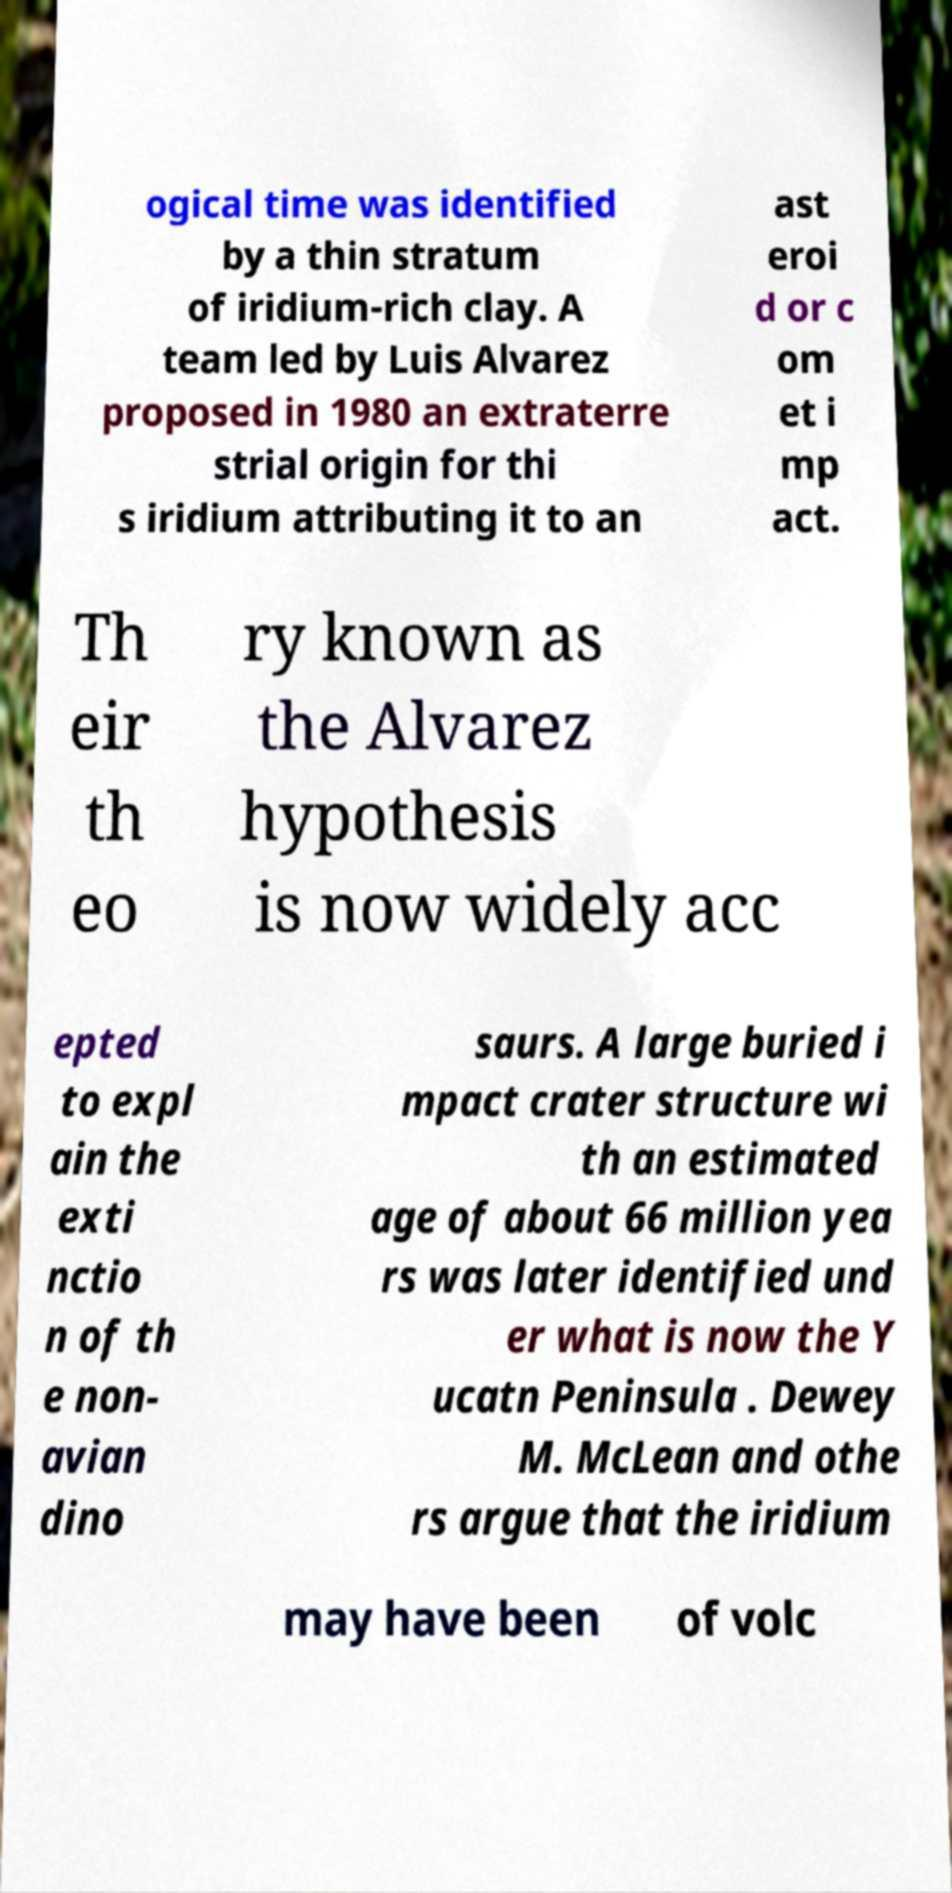Could you extract and type out the text from this image? ogical time was identified by a thin stratum of iridium-rich clay. A team led by Luis Alvarez proposed in 1980 an extraterre strial origin for thi s iridium attributing it to an ast eroi d or c om et i mp act. Th eir th eo ry known as the Alvarez hypothesis is now widely acc epted to expl ain the exti nctio n of th e non- avian dino saurs. A large buried i mpact crater structure wi th an estimated age of about 66 million yea rs was later identified und er what is now the Y ucatn Peninsula . Dewey M. McLean and othe rs argue that the iridium may have been of volc 